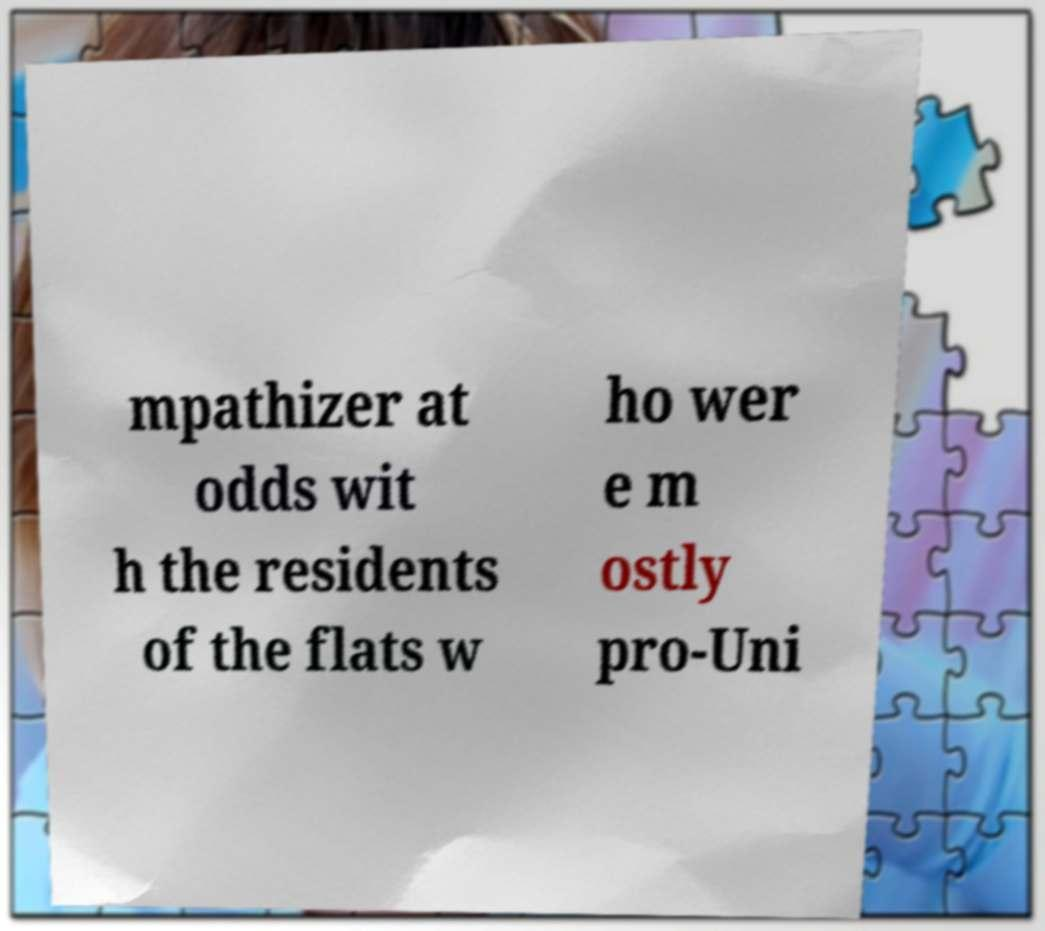Can you read and provide the text displayed in the image?This photo seems to have some interesting text. Can you extract and type it out for me? mpathizer at odds wit h the residents of the flats w ho wer e m ostly pro-Uni 